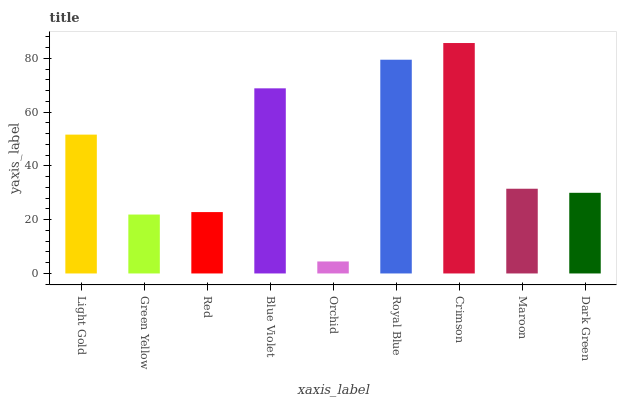Is Orchid the minimum?
Answer yes or no. Yes. Is Crimson the maximum?
Answer yes or no. Yes. Is Green Yellow the minimum?
Answer yes or no. No. Is Green Yellow the maximum?
Answer yes or no. No. Is Light Gold greater than Green Yellow?
Answer yes or no. Yes. Is Green Yellow less than Light Gold?
Answer yes or no. Yes. Is Green Yellow greater than Light Gold?
Answer yes or no. No. Is Light Gold less than Green Yellow?
Answer yes or no. No. Is Maroon the high median?
Answer yes or no. Yes. Is Maroon the low median?
Answer yes or no. Yes. Is Blue Violet the high median?
Answer yes or no. No. Is Red the low median?
Answer yes or no. No. 